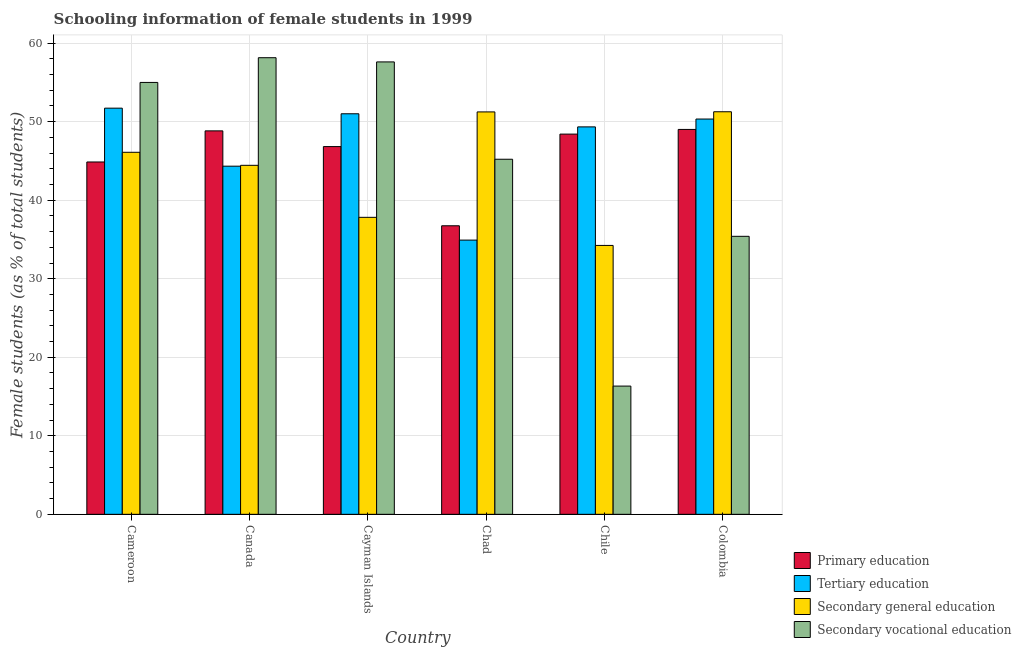How many different coloured bars are there?
Keep it short and to the point. 4. Are the number of bars per tick equal to the number of legend labels?
Your response must be concise. Yes. Are the number of bars on each tick of the X-axis equal?
Give a very brief answer. Yes. What is the label of the 3rd group of bars from the left?
Offer a very short reply. Cayman Islands. In how many cases, is the number of bars for a given country not equal to the number of legend labels?
Offer a very short reply. 0. What is the percentage of female students in primary education in Chad?
Keep it short and to the point. 36.74. Across all countries, what is the maximum percentage of female students in secondary education?
Provide a succinct answer. 51.26. Across all countries, what is the minimum percentage of female students in primary education?
Make the answer very short. 36.74. In which country was the percentage of female students in tertiary education maximum?
Make the answer very short. Cameroon. What is the total percentage of female students in primary education in the graph?
Keep it short and to the point. 274.69. What is the difference between the percentage of female students in tertiary education in Cameroon and that in Chad?
Make the answer very short. 16.8. What is the difference between the percentage of female students in secondary vocational education in Chad and the percentage of female students in primary education in Canada?
Your answer should be compact. -3.61. What is the average percentage of female students in tertiary education per country?
Your response must be concise. 46.94. What is the difference between the percentage of female students in secondary vocational education and percentage of female students in primary education in Cayman Islands?
Offer a terse response. 10.78. What is the ratio of the percentage of female students in primary education in Canada to that in Chile?
Offer a very short reply. 1.01. Is the difference between the percentage of female students in tertiary education in Cameroon and Chile greater than the difference between the percentage of female students in secondary vocational education in Cameroon and Chile?
Keep it short and to the point. No. What is the difference between the highest and the second highest percentage of female students in secondary education?
Offer a terse response. 0.02. What is the difference between the highest and the lowest percentage of female students in secondary education?
Make the answer very short. 17.02. Is it the case that in every country, the sum of the percentage of female students in secondary vocational education and percentage of female students in primary education is greater than the sum of percentage of female students in secondary education and percentage of female students in tertiary education?
Make the answer very short. No. What does the 4th bar from the left in Chad represents?
Ensure brevity in your answer.  Secondary vocational education. What does the 4th bar from the right in Cayman Islands represents?
Make the answer very short. Primary education. How many bars are there?
Your answer should be compact. 24. What is the difference between two consecutive major ticks on the Y-axis?
Provide a short and direct response. 10. Are the values on the major ticks of Y-axis written in scientific E-notation?
Give a very brief answer. No. Does the graph contain grids?
Give a very brief answer. Yes. Where does the legend appear in the graph?
Your answer should be very brief. Bottom right. How are the legend labels stacked?
Your answer should be compact. Vertical. What is the title of the graph?
Make the answer very short. Schooling information of female students in 1999. Does "Luxembourg" appear as one of the legend labels in the graph?
Your answer should be very brief. No. What is the label or title of the X-axis?
Provide a short and direct response. Country. What is the label or title of the Y-axis?
Your answer should be very brief. Female students (as % of total students). What is the Female students (as % of total students) of Primary education in Cameroon?
Make the answer very short. 44.87. What is the Female students (as % of total students) in Tertiary education in Cameroon?
Give a very brief answer. 51.72. What is the Female students (as % of total students) in Secondary general education in Cameroon?
Provide a short and direct response. 46.1. What is the Female students (as % of total students) in Secondary vocational education in Cameroon?
Give a very brief answer. 55. What is the Female students (as % of total students) in Primary education in Canada?
Provide a short and direct response. 48.83. What is the Female students (as % of total students) of Tertiary education in Canada?
Your response must be concise. 44.33. What is the Female students (as % of total students) of Secondary general education in Canada?
Make the answer very short. 44.44. What is the Female students (as % of total students) in Secondary vocational education in Canada?
Keep it short and to the point. 58.14. What is the Female students (as % of total students) in Primary education in Cayman Islands?
Your answer should be very brief. 46.83. What is the Female students (as % of total students) in Tertiary education in Cayman Islands?
Provide a short and direct response. 51. What is the Female students (as % of total students) in Secondary general education in Cayman Islands?
Offer a very short reply. 37.82. What is the Female students (as % of total students) in Secondary vocational education in Cayman Islands?
Your answer should be compact. 57.61. What is the Female students (as % of total students) of Primary education in Chad?
Ensure brevity in your answer.  36.74. What is the Female students (as % of total students) in Tertiary education in Chad?
Your answer should be compact. 34.92. What is the Female students (as % of total students) of Secondary general education in Chad?
Your answer should be compact. 51.24. What is the Female students (as % of total students) of Secondary vocational education in Chad?
Your response must be concise. 45.22. What is the Female students (as % of total students) in Primary education in Chile?
Keep it short and to the point. 48.42. What is the Female students (as % of total students) of Tertiary education in Chile?
Your answer should be compact. 49.34. What is the Female students (as % of total students) of Secondary general education in Chile?
Ensure brevity in your answer.  34.24. What is the Female students (as % of total students) of Secondary vocational education in Chile?
Your answer should be compact. 16.33. What is the Female students (as % of total students) of Primary education in Colombia?
Provide a succinct answer. 49.01. What is the Female students (as % of total students) of Tertiary education in Colombia?
Make the answer very short. 50.33. What is the Female students (as % of total students) in Secondary general education in Colombia?
Provide a succinct answer. 51.26. What is the Female students (as % of total students) in Secondary vocational education in Colombia?
Give a very brief answer. 35.4. Across all countries, what is the maximum Female students (as % of total students) in Primary education?
Ensure brevity in your answer.  49.01. Across all countries, what is the maximum Female students (as % of total students) in Tertiary education?
Ensure brevity in your answer.  51.72. Across all countries, what is the maximum Female students (as % of total students) of Secondary general education?
Give a very brief answer. 51.26. Across all countries, what is the maximum Female students (as % of total students) of Secondary vocational education?
Give a very brief answer. 58.14. Across all countries, what is the minimum Female students (as % of total students) in Primary education?
Make the answer very short. 36.74. Across all countries, what is the minimum Female students (as % of total students) of Tertiary education?
Your answer should be very brief. 34.92. Across all countries, what is the minimum Female students (as % of total students) of Secondary general education?
Make the answer very short. 34.24. Across all countries, what is the minimum Female students (as % of total students) of Secondary vocational education?
Keep it short and to the point. 16.33. What is the total Female students (as % of total students) of Primary education in the graph?
Your answer should be very brief. 274.69. What is the total Female students (as % of total students) in Tertiary education in the graph?
Provide a short and direct response. 281.64. What is the total Female students (as % of total students) of Secondary general education in the graph?
Make the answer very short. 265.1. What is the total Female students (as % of total students) of Secondary vocational education in the graph?
Your response must be concise. 267.69. What is the difference between the Female students (as % of total students) in Primary education in Cameroon and that in Canada?
Ensure brevity in your answer.  -3.96. What is the difference between the Female students (as % of total students) of Tertiary education in Cameroon and that in Canada?
Your answer should be compact. 7.39. What is the difference between the Female students (as % of total students) in Secondary general education in Cameroon and that in Canada?
Provide a succinct answer. 1.66. What is the difference between the Female students (as % of total students) in Secondary vocational education in Cameroon and that in Canada?
Provide a short and direct response. -3.15. What is the difference between the Female students (as % of total students) of Primary education in Cameroon and that in Cayman Islands?
Your response must be concise. -1.96. What is the difference between the Female students (as % of total students) of Tertiary education in Cameroon and that in Cayman Islands?
Offer a terse response. 0.72. What is the difference between the Female students (as % of total students) in Secondary general education in Cameroon and that in Cayman Islands?
Make the answer very short. 8.28. What is the difference between the Female students (as % of total students) in Secondary vocational education in Cameroon and that in Cayman Islands?
Offer a terse response. -2.61. What is the difference between the Female students (as % of total students) of Primary education in Cameroon and that in Chad?
Your answer should be compact. 8.12. What is the difference between the Female students (as % of total students) of Tertiary education in Cameroon and that in Chad?
Offer a terse response. 16.8. What is the difference between the Female students (as % of total students) in Secondary general education in Cameroon and that in Chad?
Your answer should be very brief. -5.14. What is the difference between the Female students (as % of total students) in Secondary vocational education in Cameroon and that in Chad?
Provide a succinct answer. 9.78. What is the difference between the Female students (as % of total students) in Primary education in Cameroon and that in Chile?
Ensure brevity in your answer.  -3.55. What is the difference between the Female students (as % of total students) in Tertiary education in Cameroon and that in Chile?
Ensure brevity in your answer.  2.38. What is the difference between the Female students (as % of total students) of Secondary general education in Cameroon and that in Chile?
Your response must be concise. 11.86. What is the difference between the Female students (as % of total students) in Secondary vocational education in Cameroon and that in Chile?
Provide a succinct answer. 38.67. What is the difference between the Female students (as % of total students) of Primary education in Cameroon and that in Colombia?
Offer a very short reply. -4.15. What is the difference between the Female students (as % of total students) in Tertiary education in Cameroon and that in Colombia?
Your answer should be compact. 1.39. What is the difference between the Female students (as % of total students) in Secondary general education in Cameroon and that in Colombia?
Your answer should be very brief. -5.16. What is the difference between the Female students (as % of total students) in Secondary vocational education in Cameroon and that in Colombia?
Offer a terse response. 19.6. What is the difference between the Female students (as % of total students) of Primary education in Canada and that in Cayman Islands?
Offer a very short reply. 2. What is the difference between the Female students (as % of total students) of Tertiary education in Canada and that in Cayman Islands?
Your answer should be very brief. -6.67. What is the difference between the Female students (as % of total students) in Secondary general education in Canada and that in Cayman Islands?
Provide a short and direct response. 6.62. What is the difference between the Female students (as % of total students) of Secondary vocational education in Canada and that in Cayman Islands?
Provide a short and direct response. 0.54. What is the difference between the Female students (as % of total students) of Primary education in Canada and that in Chad?
Give a very brief answer. 12.08. What is the difference between the Female students (as % of total students) in Tertiary education in Canada and that in Chad?
Offer a terse response. 9.41. What is the difference between the Female students (as % of total students) in Secondary vocational education in Canada and that in Chad?
Give a very brief answer. 12.93. What is the difference between the Female students (as % of total students) in Primary education in Canada and that in Chile?
Keep it short and to the point. 0.41. What is the difference between the Female students (as % of total students) in Tertiary education in Canada and that in Chile?
Make the answer very short. -5. What is the difference between the Female students (as % of total students) of Secondary general education in Canada and that in Chile?
Provide a succinct answer. 10.2. What is the difference between the Female students (as % of total students) of Secondary vocational education in Canada and that in Chile?
Your answer should be compact. 41.82. What is the difference between the Female students (as % of total students) of Primary education in Canada and that in Colombia?
Provide a succinct answer. -0.18. What is the difference between the Female students (as % of total students) of Tertiary education in Canada and that in Colombia?
Your answer should be very brief. -6. What is the difference between the Female students (as % of total students) of Secondary general education in Canada and that in Colombia?
Keep it short and to the point. -6.82. What is the difference between the Female students (as % of total students) in Secondary vocational education in Canada and that in Colombia?
Offer a terse response. 22.75. What is the difference between the Female students (as % of total students) of Primary education in Cayman Islands and that in Chad?
Give a very brief answer. 10.09. What is the difference between the Female students (as % of total students) in Tertiary education in Cayman Islands and that in Chad?
Make the answer very short. 16.09. What is the difference between the Female students (as % of total students) of Secondary general education in Cayman Islands and that in Chad?
Your answer should be compact. -13.42. What is the difference between the Female students (as % of total students) of Secondary vocational education in Cayman Islands and that in Chad?
Your response must be concise. 12.39. What is the difference between the Female students (as % of total students) of Primary education in Cayman Islands and that in Chile?
Your answer should be compact. -1.59. What is the difference between the Female students (as % of total students) of Tertiary education in Cayman Islands and that in Chile?
Make the answer very short. 1.67. What is the difference between the Female students (as % of total students) of Secondary general education in Cayman Islands and that in Chile?
Give a very brief answer. 3.58. What is the difference between the Female students (as % of total students) of Secondary vocational education in Cayman Islands and that in Chile?
Ensure brevity in your answer.  41.28. What is the difference between the Female students (as % of total students) in Primary education in Cayman Islands and that in Colombia?
Give a very brief answer. -2.18. What is the difference between the Female students (as % of total students) of Tertiary education in Cayman Islands and that in Colombia?
Provide a short and direct response. 0.67. What is the difference between the Female students (as % of total students) in Secondary general education in Cayman Islands and that in Colombia?
Keep it short and to the point. -13.45. What is the difference between the Female students (as % of total students) in Secondary vocational education in Cayman Islands and that in Colombia?
Your response must be concise. 22.21. What is the difference between the Female students (as % of total students) in Primary education in Chad and that in Chile?
Offer a terse response. -11.67. What is the difference between the Female students (as % of total students) of Tertiary education in Chad and that in Chile?
Your answer should be compact. -14.42. What is the difference between the Female students (as % of total students) in Secondary general education in Chad and that in Chile?
Your answer should be very brief. 17. What is the difference between the Female students (as % of total students) of Secondary vocational education in Chad and that in Chile?
Your answer should be very brief. 28.89. What is the difference between the Female students (as % of total students) of Primary education in Chad and that in Colombia?
Keep it short and to the point. -12.27. What is the difference between the Female students (as % of total students) of Tertiary education in Chad and that in Colombia?
Make the answer very short. -15.42. What is the difference between the Female students (as % of total students) in Secondary general education in Chad and that in Colombia?
Provide a short and direct response. -0.02. What is the difference between the Female students (as % of total students) in Secondary vocational education in Chad and that in Colombia?
Your answer should be compact. 9.82. What is the difference between the Female students (as % of total students) in Primary education in Chile and that in Colombia?
Ensure brevity in your answer.  -0.59. What is the difference between the Female students (as % of total students) of Tertiary education in Chile and that in Colombia?
Give a very brief answer. -1. What is the difference between the Female students (as % of total students) in Secondary general education in Chile and that in Colombia?
Ensure brevity in your answer.  -17.02. What is the difference between the Female students (as % of total students) in Secondary vocational education in Chile and that in Colombia?
Keep it short and to the point. -19.07. What is the difference between the Female students (as % of total students) in Primary education in Cameroon and the Female students (as % of total students) in Tertiary education in Canada?
Offer a terse response. 0.53. What is the difference between the Female students (as % of total students) of Primary education in Cameroon and the Female students (as % of total students) of Secondary general education in Canada?
Provide a succinct answer. 0.42. What is the difference between the Female students (as % of total students) of Primary education in Cameroon and the Female students (as % of total students) of Secondary vocational education in Canada?
Make the answer very short. -13.28. What is the difference between the Female students (as % of total students) in Tertiary education in Cameroon and the Female students (as % of total students) in Secondary general education in Canada?
Ensure brevity in your answer.  7.28. What is the difference between the Female students (as % of total students) of Tertiary education in Cameroon and the Female students (as % of total students) of Secondary vocational education in Canada?
Provide a short and direct response. -6.42. What is the difference between the Female students (as % of total students) of Secondary general education in Cameroon and the Female students (as % of total students) of Secondary vocational education in Canada?
Offer a very short reply. -12.04. What is the difference between the Female students (as % of total students) in Primary education in Cameroon and the Female students (as % of total students) in Tertiary education in Cayman Islands?
Ensure brevity in your answer.  -6.14. What is the difference between the Female students (as % of total students) of Primary education in Cameroon and the Female students (as % of total students) of Secondary general education in Cayman Islands?
Give a very brief answer. 7.05. What is the difference between the Female students (as % of total students) in Primary education in Cameroon and the Female students (as % of total students) in Secondary vocational education in Cayman Islands?
Your response must be concise. -12.74. What is the difference between the Female students (as % of total students) of Tertiary education in Cameroon and the Female students (as % of total students) of Secondary general education in Cayman Islands?
Make the answer very short. 13.9. What is the difference between the Female students (as % of total students) in Tertiary education in Cameroon and the Female students (as % of total students) in Secondary vocational education in Cayman Islands?
Your answer should be very brief. -5.89. What is the difference between the Female students (as % of total students) in Secondary general education in Cameroon and the Female students (as % of total students) in Secondary vocational education in Cayman Islands?
Provide a succinct answer. -11.51. What is the difference between the Female students (as % of total students) of Primary education in Cameroon and the Female students (as % of total students) of Tertiary education in Chad?
Keep it short and to the point. 9.95. What is the difference between the Female students (as % of total students) in Primary education in Cameroon and the Female students (as % of total students) in Secondary general education in Chad?
Offer a very short reply. -6.38. What is the difference between the Female students (as % of total students) in Primary education in Cameroon and the Female students (as % of total students) in Secondary vocational education in Chad?
Provide a succinct answer. -0.35. What is the difference between the Female students (as % of total students) of Tertiary education in Cameroon and the Female students (as % of total students) of Secondary general education in Chad?
Your response must be concise. 0.48. What is the difference between the Female students (as % of total students) in Tertiary education in Cameroon and the Female students (as % of total students) in Secondary vocational education in Chad?
Give a very brief answer. 6.5. What is the difference between the Female students (as % of total students) in Secondary general education in Cameroon and the Female students (as % of total students) in Secondary vocational education in Chad?
Your response must be concise. 0.88. What is the difference between the Female students (as % of total students) in Primary education in Cameroon and the Female students (as % of total students) in Tertiary education in Chile?
Give a very brief answer. -4.47. What is the difference between the Female students (as % of total students) in Primary education in Cameroon and the Female students (as % of total students) in Secondary general education in Chile?
Give a very brief answer. 10.63. What is the difference between the Female students (as % of total students) of Primary education in Cameroon and the Female students (as % of total students) of Secondary vocational education in Chile?
Offer a terse response. 28.54. What is the difference between the Female students (as % of total students) of Tertiary education in Cameroon and the Female students (as % of total students) of Secondary general education in Chile?
Ensure brevity in your answer.  17.48. What is the difference between the Female students (as % of total students) of Tertiary education in Cameroon and the Female students (as % of total students) of Secondary vocational education in Chile?
Give a very brief answer. 35.39. What is the difference between the Female students (as % of total students) in Secondary general education in Cameroon and the Female students (as % of total students) in Secondary vocational education in Chile?
Ensure brevity in your answer.  29.77. What is the difference between the Female students (as % of total students) of Primary education in Cameroon and the Female students (as % of total students) of Tertiary education in Colombia?
Provide a short and direct response. -5.47. What is the difference between the Female students (as % of total students) in Primary education in Cameroon and the Female students (as % of total students) in Secondary general education in Colombia?
Provide a succinct answer. -6.4. What is the difference between the Female students (as % of total students) of Primary education in Cameroon and the Female students (as % of total students) of Secondary vocational education in Colombia?
Your answer should be compact. 9.47. What is the difference between the Female students (as % of total students) in Tertiary education in Cameroon and the Female students (as % of total students) in Secondary general education in Colombia?
Your answer should be very brief. 0.46. What is the difference between the Female students (as % of total students) in Tertiary education in Cameroon and the Female students (as % of total students) in Secondary vocational education in Colombia?
Keep it short and to the point. 16.32. What is the difference between the Female students (as % of total students) of Secondary general education in Cameroon and the Female students (as % of total students) of Secondary vocational education in Colombia?
Provide a short and direct response. 10.7. What is the difference between the Female students (as % of total students) of Primary education in Canada and the Female students (as % of total students) of Tertiary education in Cayman Islands?
Your answer should be compact. -2.18. What is the difference between the Female students (as % of total students) in Primary education in Canada and the Female students (as % of total students) in Secondary general education in Cayman Islands?
Offer a very short reply. 11.01. What is the difference between the Female students (as % of total students) in Primary education in Canada and the Female students (as % of total students) in Secondary vocational education in Cayman Islands?
Your response must be concise. -8.78. What is the difference between the Female students (as % of total students) in Tertiary education in Canada and the Female students (as % of total students) in Secondary general education in Cayman Islands?
Make the answer very short. 6.51. What is the difference between the Female students (as % of total students) of Tertiary education in Canada and the Female students (as % of total students) of Secondary vocational education in Cayman Islands?
Your response must be concise. -13.28. What is the difference between the Female students (as % of total students) of Secondary general education in Canada and the Female students (as % of total students) of Secondary vocational education in Cayman Islands?
Give a very brief answer. -13.17. What is the difference between the Female students (as % of total students) in Primary education in Canada and the Female students (as % of total students) in Tertiary education in Chad?
Offer a very short reply. 13.91. What is the difference between the Female students (as % of total students) of Primary education in Canada and the Female students (as % of total students) of Secondary general education in Chad?
Offer a terse response. -2.41. What is the difference between the Female students (as % of total students) in Primary education in Canada and the Female students (as % of total students) in Secondary vocational education in Chad?
Ensure brevity in your answer.  3.61. What is the difference between the Female students (as % of total students) in Tertiary education in Canada and the Female students (as % of total students) in Secondary general education in Chad?
Offer a very short reply. -6.91. What is the difference between the Female students (as % of total students) in Tertiary education in Canada and the Female students (as % of total students) in Secondary vocational education in Chad?
Provide a short and direct response. -0.88. What is the difference between the Female students (as % of total students) of Secondary general education in Canada and the Female students (as % of total students) of Secondary vocational education in Chad?
Your answer should be compact. -0.77. What is the difference between the Female students (as % of total students) of Primary education in Canada and the Female students (as % of total students) of Tertiary education in Chile?
Ensure brevity in your answer.  -0.51. What is the difference between the Female students (as % of total students) in Primary education in Canada and the Female students (as % of total students) in Secondary general education in Chile?
Your answer should be compact. 14.59. What is the difference between the Female students (as % of total students) in Primary education in Canada and the Female students (as % of total students) in Secondary vocational education in Chile?
Keep it short and to the point. 32.5. What is the difference between the Female students (as % of total students) in Tertiary education in Canada and the Female students (as % of total students) in Secondary general education in Chile?
Make the answer very short. 10.09. What is the difference between the Female students (as % of total students) of Tertiary education in Canada and the Female students (as % of total students) of Secondary vocational education in Chile?
Your answer should be very brief. 28. What is the difference between the Female students (as % of total students) in Secondary general education in Canada and the Female students (as % of total students) in Secondary vocational education in Chile?
Provide a succinct answer. 28.11. What is the difference between the Female students (as % of total students) of Primary education in Canada and the Female students (as % of total students) of Tertiary education in Colombia?
Give a very brief answer. -1.51. What is the difference between the Female students (as % of total students) in Primary education in Canada and the Female students (as % of total students) in Secondary general education in Colombia?
Your answer should be compact. -2.44. What is the difference between the Female students (as % of total students) of Primary education in Canada and the Female students (as % of total students) of Secondary vocational education in Colombia?
Keep it short and to the point. 13.43. What is the difference between the Female students (as % of total students) in Tertiary education in Canada and the Female students (as % of total students) in Secondary general education in Colombia?
Give a very brief answer. -6.93. What is the difference between the Female students (as % of total students) of Tertiary education in Canada and the Female students (as % of total students) of Secondary vocational education in Colombia?
Ensure brevity in your answer.  8.93. What is the difference between the Female students (as % of total students) of Secondary general education in Canada and the Female students (as % of total students) of Secondary vocational education in Colombia?
Make the answer very short. 9.04. What is the difference between the Female students (as % of total students) in Primary education in Cayman Islands and the Female students (as % of total students) in Tertiary education in Chad?
Your answer should be very brief. 11.91. What is the difference between the Female students (as % of total students) in Primary education in Cayman Islands and the Female students (as % of total students) in Secondary general education in Chad?
Your response must be concise. -4.41. What is the difference between the Female students (as % of total students) in Primary education in Cayman Islands and the Female students (as % of total students) in Secondary vocational education in Chad?
Ensure brevity in your answer.  1.61. What is the difference between the Female students (as % of total students) in Tertiary education in Cayman Islands and the Female students (as % of total students) in Secondary general education in Chad?
Your answer should be very brief. -0.24. What is the difference between the Female students (as % of total students) of Tertiary education in Cayman Islands and the Female students (as % of total students) of Secondary vocational education in Chad?
Offer a very short reply. 5.79. What is the difference between the Female students (as % of total students) in Secondary general education in Cayman Islands and the Female students (as % of total students) in Secondary vocational education in Chad?
Your response must be concise. -7.4. What is the difference between the Female students (as % of total students) of Primary education in Cayman Islands and the Female students (as % of total students) of Tertiary education in Chile?
Ensure brevity in your answer.  -2.51. What is the difference between the Female students (as % of total students) in Primary education in Cayman Islands and the Female students (as % of total students) in Secondary general education in Chile?
Ensure brevity in your answer.  12.59. What is the difference between the Female students (as % of total students) of Primary education in Cayman Islands and the Female students (as % of total students) of Secondary vocational education in Chile?
Ensure brevity in your answer.  30.5. What is the difference between the Female students (as % of total students) of Tertiary education in Cayman Islands and the Female students (as % of total students) of Secondary general education in Chile?
Keep it short and to the point. 16.77. What is the difference between the Female students (as % of total students) in Tertiary education in Cayman Islands and the Female students (as % of total students) in Secondary vocational education in Chile?
Offer a terse response. 34.68. What is the difference between the Female students (as % of total students) in Secondary general education in Cayman Islands and the Female students (as % of total students) in Secondary vocational education in Chile?
Offer a terse response. 21.49. What is the difference between the Female students (as % of total students) of Primary education in Cayman Islands and the Female students (as % of total students) of Tertiary education in Colombia?
Offer a very short reply. -3.51. What is the difference between the Female students (as % of total students) of Primary education in Cayman Islands and the Female students (as % of total students) of Secondary general education in Colombia?
Make the answer very short. -4.43. What is the difference between the Female students (as % of total students) of Primary education in Cayman Islands and the Female students (as % of total students) of Secondary vocational education in Colombia?
Keep it short and to the point. 11.43. What is the difference between the Female students (as % of total students) of Tertiary education in Cayman Islands and the Female students (as % of total students) of Secondary general education in Colombia?
Your response must be concise. -0.26. What is the difference between the Female students (as % of total students) in Tertiary education in Cayman Islands and the Female students (as % of total students) in Secondary vocational education in Colombia?
Your answer should be very brief. 15.61. What is the difference between the Female students (as % of total students) of Secondary general education in Cayman Islands and the Female students (as % of total students) of Secondary vocational education in Colombia?
Provide a succinct answer. 2.42. What is the difference between the Female students (as % of total students) of Primary education in Chad and the Female students (as % of total students) of Tertiary education in Chile?
Your answer should be compact. -12.59. What is the difference between the Female students (as % of total students) of Primary education in Chad and the Female students (as % of total students) of Secondary general education in Chile?
Offer a terse response. 2.5. What is the difference between the Female students (as % of total students) of Primary education in Chad and the Female students (as % of total students) of Secondary vocational education in Chile?
Ensure brevity in your answer.  20.41. What is the difference between the Female students (as % of total students) in Tertiary education in Chad and the Female students (as % of total students) in Secondary general education in Chile?
Offer a terse response. 0.68. What is the difference between the Female students (as % of total students) in Tertiary education in Chad and the Female students (as % of total students) in Secondary vocational education in Chile?
Provide a succinct answer. 18.59. What is the difference between the Female students (as % of total students) in Secondary general education in Chad and the Female students (as % of total students) in Secondary vocational education in Chile?
Offer a very short reply. 34.91. What is the difference between the Female students (as % of total students) in Primary education in Chad and the Female students (as % of total students) in Tertiary education in Colombia?
Provide a short and direct response. -13.59. What is the difference between the Female students (as % of total students) in Primary education in Chad and the Female students (as % of total students) in Secondary general education in Colombia?
Offer a terse response. -14.52. What is the difference between the Female students (as % of total students) in Primary education in Chad and the Female students (as % of total students) in Secondary vocational education in Colombia?
Give a very brief answer. 1.34. What is the difference between the Female students (as % of total students) of Tertiary education in Chad and the Female students (as % of total students) of Secondary general education in Colombia?
Offer a terse response. -16.34. What is the difference between the Female students (as % of total students) in Tertiary education in Chad and the Female students (as % of total students) in Secondary vocational education in Colombia?
Keep it short and to the point. -0.48. What is the difference between the Female students (as % of total students) in Secondary general education in Chad and the Female students (as % of total students) in Secondary vocational education in Colombia?
Your answer should be compact. 15.84. What is the difference between the Female students (as % of total students) in Primary education in Chile and the Female students (as % of total students) in Tertiary education in Colombia?
Your answer should be compact. -1.92. What is the difference between the Female students (as % of total students) of Primary education in Chile and the Female students (as % of total students) of Secondary general education in Colombia?
Give a very brief answer. -2.85. What is the difference between the Female students (as % of total students) in Primary education in Chile and the Female students (as % of total students) in Secondary vocational education in Colombia?
Your response must be concise. 13.02. What is the difference between the Female students (as % of total students) in Tertiary education in Chile and the Female students (as % of total students) in Secondary general education in Colombia?
Offer a terse response. -1.93. What is the difference between the Female students (as % of total students) in Tertiary education in Chile and the Female students (as % of total students) in Secondary vocational education in Colombia?
Ensure brevity in your answer.  13.94. What is the difference between the Female students (as % of total students) in Secondary general education in Chile and the Female students (as % of total students) in Secondary vocational education in Colombia?
Provide a short and direct response. -1.16. What is the average Female students (as % of total students) of Primary education per country?
Offer a very short reply. 45.78. What is the average Female students (as % of total students) of Tertiary education per country?
Provide a succinct answer. 46.94. What is the average Female students (as % of total students) of Secondary general education per country?
Your answer should be compact. 44.18. What is the average Female students (as % of total students) in Secondary vocational education per country?
Offer a very short reply. 44.62. What is the difference between the Female students (as % of total students) of Primary education and Female students (as % of total students) of Tertiary education in Cameroon?
Offer a very short reply. -6.85. What is the difference between the Female students (as % of total students) in Primary education and Female students (as % of total students) in Secondary general education in Cameroon?
Provide a short and direct response. -1.23. What is the difference between the Female students (as % of total students) of Primary education and Female students (as % of total students) of Secondary vocational education in Cameroon?
Keep it short and to the point. -10.13. What is the difference between the Female students (as % of total students) in Tertiary education and Female students (as % of total students) in Secondary general education in Cameroon?
Provide a succinct answer. 5.62. What is the difference between the Female students (as % of total students) of Tertiary education and Female students (as % of total students) of Secondary vocational education in Cameroon?
Provide a short and direct response. -3.28. What is the difference between the Female students (as % of total students) in Secondary general education and Female students (as % of total students) in Secondary vocational education in Cameroon?
Ensure brevity in your answer.  -8.9. What is the difference between the Female students (as % of total students) in Primary education and Female students (as % of total students) in Tertiary education in Canada?
Offer a terse response. 4.5. What is the difference between the Female students (as % of total students) of Primary education and Female students (as % of total students) of Secondary general education in Canada?
Your answer should be compact. 4.39. What is the difference between the Female students (as % of total students) of Primary education and Female students (as % of total students) of Secondary vocational education in Canada?
Offer a very short reply. -9.32. What is the difference between the Female students (as % of total students) in Tertiary education and Female students (as % of total students) in Secondary general education in Canada?
Give a very brief answer. -0.11. What is the difference between the Female students (as % of total students) of Tertiary education and Female students (as % of total students) of Secondary vocational education in Canada?
Give a very brief answer. -13.81. What is the difference between the Female students (as % of total students) of Secondary general education and Female students (as % of total students) of Secondary vocational education in Canada?
Give a very brief answer. -13.7. What is the difference between the Female students (as % of total students) in Primary education and Female students (as % of total students) in Tertiary education in Cayman Islands?
Give a very brief answer. -4.18. What is the difference between the Female students (as % of total students) of Primary education and Female students (as % of total students) of Secondary general education in Cayman Islands?
Provide a succinct answer. 9.01. What is the difference between the Female students (as % of total students) in Primary education and Female students (as % of total students) in Secondary vocational education in Cayman Islands?
Offer a terse response. -10.78. What is the difference between the Female students (as % of total students) of Tertiary education and Female students (as % of total students) of Secondary general education in Cayman Islands?
Offer a very short reply. 13.19. What is the difference between the Female students (as % of total students) of Tertiary education and Female students (as % of total students) of Secondary vocational education in Cayman Islands?
Offer a terse response. -6.6. What is the difference between the Female students (as % of total students) in Secondary general education and Female students (as % of total students) in Secondary vocational education in Cayman Islands?
Make the answer very short. -19.79. What is the difference between the Female students (as % of total students) of Primary education and Female students (as % of total students) of Tertiary education in Chad?
Your answer should be compact. 1.82. What is the difference between the Female students (as % of total students) of Primary education and Female students (as % of total students) of Secondary general education in Chad?
Your answer should be compact. -14.5. What is the difference between the Female students (as % of total students) in Primary education and Female students (as % of total students) in Secondary vocational education in Chad?
Give a very brief answer. -8.47. What is the difference between the Female students (as % of total students) in Tertiary education and Female students (as % of total students) in Secondary general education in Chad?
Make the answer very short. -16.32. What is the difference between the Female students (as % of total students) in Tertiary education and Female students (as % of total students) in Secondary vocational education in Chad?
Make the answer very short. -10.3. What is the difference between the Female students (as % of total students) of Secondary general education and Female students (as % of total students) of Secondary vocational education in Chad?
Provide a succinct answer. 6.03. What is the difference between the Female students (as % of total students) in Primary education and Female students (as % of total students) in Tertiary education in Chile?
Your answer should be compact. -0.92. What is the difference between the Female students (as % of total students) in Primary education and Female students (as % of total students) in Secondary general education in Chile?
Make the answer very short. 14.18. What is the difference between the Female students (as % of total students) in Primary education and Female students (as % of total students) in Secondary vocational education in Chile?
Provide a short and direct response. 32.09. What is the difference between the Female students (as % of total students) of Tertiary education and Female students (as % of total students) of Secondary general education in Chile?
Keep it short and to the point. 15.1. What is the difference between the Female students (as % of total students) in Tertiary education and Female students (as % of total students) in Secondary vocational education in Chile?
Provide a short and direct response. 33.01. What is the difference between the Female students (as % of total students) in Secondary general education and Female students (as % of total students) in Secondary vocational education in Chile?
Your answer should be very brief. 17.91. What is the difference between the Female students (as % of total students) of Primary education and Female students (as % of total students) of Tertiary education in Colombia?
Your answer should be very brief. -1.32. What is the difference between the Female students (as % of total students) in Primary education and Female students (as % of total students) in Secondary general education in Colombia?
Keep it short and to the point. -2.25. What is the difference between the Female students (as % of total students) in Primary education and Female students (as % of total students) in Secondary vocational education in Colombia?
Ensure brevity in your answer.  13.61. What is the difference between the Female students (as % of total students) in Tertiary education and Female students (as % of total students) in Secondary general education in Colombia?
Provide a succinct answer. -0.93. What is the difference between the Female students (as % of total students) in Tertiary education and Female students (as % of total students) in Secondary vocational education in Colombia?
Your answer should be compact. 14.94. What is the difference between the Female students (as % of total students) in Secondary general education and Female students (as % of total students) in Secondary vocational education in Colombia?
Offer a terse response. 15.86. What is the ratio of the Female students (as % of total students) in Primary education in Cameroon to that in Canada?
Your answer should be very brief. 0.92. What is the ratio of the Female students (as % of total students) in Secondary general education in Cameroon to that in Canada?
Provide a short and direct response. 1.04. What is the ratio of the Female students (as % of total students) of Secondary vocational education in Cameroon to that in Canada?
Provide a short and direct response. 0.95. What is the ratio of the Female students (as % of total students) in Primary education in Cameroon to that in Cayman Islands?
Your response must be concise. 0.96. What is the ratio of the Female students (as % of total students) in Secondary general education in Cameroon to that in Cayman Islands?
Ensure brevity in your answer.  1.22. What is the ratio of the Female students (as % of total students) of Secondary vocational education in Cameroon to that in Cayman Islands?
Your response must be concise. 0.95. What is the ratio of the Female students (as % of total students) in Primary education in Cameroon to that in Chad?
Give a very brief answer. 1.22. What is the ratio of the Female students (as % of total students) in Tertiary education in Cameroon to that in Chad?
Give a very brief answer. 1.48. What is the ratio of the Female students (as % of total students) in Secondary general education in Cameroon to that in Chad?
Offer a very short reply. 0.9. What is the ratio of the Female students (as % of total students) of Secondary vocational education in Cameroon to that in Chad?
Your answer should be very brief. 1.22. What is the ratio of the Female students (as % of total students) in Primary education in Cameroon to that in Chile?
Provide a short and direct response. 0.93. What is the ratio of the Female students (as % of total students) in Tertiary education in Cameroon to that in Chile?
Your answer should be very brief. 1.05. What is the ratio of the Female students (as % of total students) of Secondary general education in Cameroon to that in Chile?
Provide a short and direct response. 1.35. What is the ratio of the Female students (as % of total students) of Secondary vocational education in Cameroon to that in Chile?
Ensure brevity in your answer.  3.37. What is the ratio of the Female students (as % of total students) in Primary education in Cameroon to that in Colombia?
Your answer should be compact. 0.92. What is the ratio of the Female students (as % of total students) of Tertiary education in Cameroon to that in Colombia?
Offer a very short reply. 1.03. What is the ratio of the Female students (as % of total students) in Secondary general education in Cameroon to that in Colombia?
Make the answer very short. 0.9. What is the ratio of the Female students (as % of total students) in Secondary vocational education in Cameroon to that in Colombia?
Your response must be concise. 1.55. What is the ratio of the Female students (as % of total students) of Primary education in Canada to that in Cayman Islands?
Your answer should be very brief. 1.04. What is the ratio of the Female students (as % of total students) of Tertiary education in Canada to that in Cayman Islands?
Make the answer very short. 0.87. What is the ratio of the Female students (as % of total students) in Secondary general education in Canada to that in Cayman Islands?
Provide a short and direct response. 1.18. What is the ratio of the Female students (as % of total students) in Secondary vocational education in Canada to that in Cayman Islands?
Make the answer very short. 1.01. What is the ratio of the Female students (as % of total students) in Primary education in Canada to that in Chad?
Offer a terse response. 1.33. What is the ratio of the Female students (as % of total students) of Tertiary education in Canada to that in Chad?
Your answer should be compact. 1.27. What is the ratio of the Female students (as % of total students) in Secondary general education in Canada to that in Chad?
Provide a short and direct response. 0.87. What is the ratio of the Female students (as % of total students) in Secondary vocational education in Canada to that in Chad?
Your response must be concise. 1.29. What is the ratio of the Female students (as % of total students) in Primary education in Canada to that in Chile?
Offer a terse response. 1.01. What is the ratio of the Female students (as % of total students) of Tertiary education in Canada to that in Chile?
Ensure brevity in your answer.  0.9. What is the ratio of the Female students (as % of total students) in Secondary general education in Canada to that in Chile?
Make the answer very short. 1.3. What is the ratio of the Female students (as % of total students) of Secondary vocational education in Canada to that in Chile?
Make the answer very short. 3.56. What is the ratio of the Female students (as % of total students) of Primary education in Canada to that in Colombia?
Offer a very short reply. 1. What is the ratio of the Female students (as % of total students) of Tertiary education in Canada to that in Colombia?
Your answer should be compact. 0.88. What is the ratio of the Female students (as % of total students) of Secondary general education in Canada to that in Colombia?
Give a very brief answer. 0.87. What is the ratio of the Female students (as % of total students) in Secondary vocational education in Canada to that in Colombia?
Provide a succinct answer. 1.64. What is the ratio of the Female students (as % of total students) of Primary education in Cayman Islands to that in Chad?
Ensure brevity in your answer.  1.27. What is the ratio of the Female students (as % of total students) in Tertiary education in Cayman Islands to that in Chad?
Keep it short and to the point. 1.46. What is the ratio of the Female students (as % of total students) of Secondary general education in Cayman Islands to that in Chad?
Offer a terse response. 0.74. What is the ratio of the Female students (as % of total students) in Secondary vocational education in Cayman Islands to that in Chad?
Ensure brevity in your answer.  1.27. What is the ratio of the Female students (as % of total students) in Primary education in Cayman Islands to that in Chile?
Give a very brief answer. 0.97. What is the ratio of the Female students (as % of total students) in Tertiary education in Cayman Islands to that in Chile?
Offer a terse response. 1.03. What is the ratio of the Female students (as % of total students) in Secondary general education in Cayman Islands to that in Chile?
Provide a short and direct response. 1.1. What is the ratio of the Female students (as % of total students) of Secondary vocational education in Cayman Islands to that in Chile?
Your answer should be very brief. 3.53. What is the ratio of the Female students (as % of total students) of Primary education in Cayman Islands to that in Colombia?
Your answer should be very brief. 0.96. What is the ratio of the Female students (as % of total students) of Tertiary education in Cayman Islands to that in Colombia?
Provide a short and direct response. 1.01. What is the ratio of the Female students (as % of total students) in Secondary general education in Cayman Islands to that in Colombia?
Your answer should be compact. 0.74. What is the ratio of the Female students (as % of total students) of Secondary vocational education in Cayman Islands to that in Colombia?
Your response must be concise. 1.63. What is the ratio of the Female students (as % of total students) in Primary education in Chad to that in Chile?
Offer a very short reply. 0.76. What is the ratio of the Female students (as % of total students) of Tertiary education in Chad to that in Chile?
Your answer should be very brief. 0.71. What is the ratio of the Female students (as % of total students) of Secondary general education in Chad to that in Chile?
Your answer should be compact. 1.5. What is the ratio of the Female students (as % of total students) of Secondary vocational education in Chad to that in Chile?
Keep it short and to the point. 2.77. What is the ratio of the Female students (as % of total students) of Primary education in Chad to that in Colombia?
Offer a very short reply. 0.75. What is the ratio of the Female students (as % of total students) of Tertiary education in Chad to that in Colombia?
Offer a very short reply. 0.69. What is the ratio of the Female students (as % of total students) in Secondary general education in Chad to that in Colombia?
Your response must be concise. 1. What is the ratio of the Female students (as % of total students) in Secondary vocational education in Chad to that in Colombia?
Give a very brief answer. 1.28. What is the ratio of the Female students (as % of total students) of Primary education in Chile to that in Colombia?
Keep it short and to the point. 0.99. What is the ratio of the Female students (as % of total students) in Tertiary education in Chile to that in Colombia?
Offer a very short reply. 0.98. What is the ratio of the Female students (as % of total students) of Secondary general education in Chile to that in Colombia?
Keep it short and to the point. 0.67. What is the ratio of the Female students (as % of total students) of Secondary vocational education in Chile to that in Colombia?
Offer a terse response. 0.46. What is the difference between the highest and the second highest Female students (as % of total students) of Primary education?
Your response must be concise. 0.18. What is the difference between the highest and the second highest Female students (as % of total students) in Tertiary education?
Your answer should be very brief. 0.72. What is the difference between the highest and the second highest Female students (as % of total students) of Secondary general education?
Your answer should be compact. 0.02. What is the difference between the highest and the second highest Female students (as % of total students) of Secondary vocational education?
Give a very brief answer. 0.54. What is the difference between the highest and the lowest Female students (as % of total students) of Primary education?
Offer a terse response. 12.27. What is the difference between the highest and the lowest Female students (as % of total students) of Tertiary education?
Your response must be concise. 16.8. What is the difference between the highest and the lowest Female students (as % of total students) in Secondary general education?
Your answer should be very brief. 17.02. What is the difference between the highest and the lowest Female students (as % of total students) of Secondary vocational education?
Your response must be concise. 41.82. 